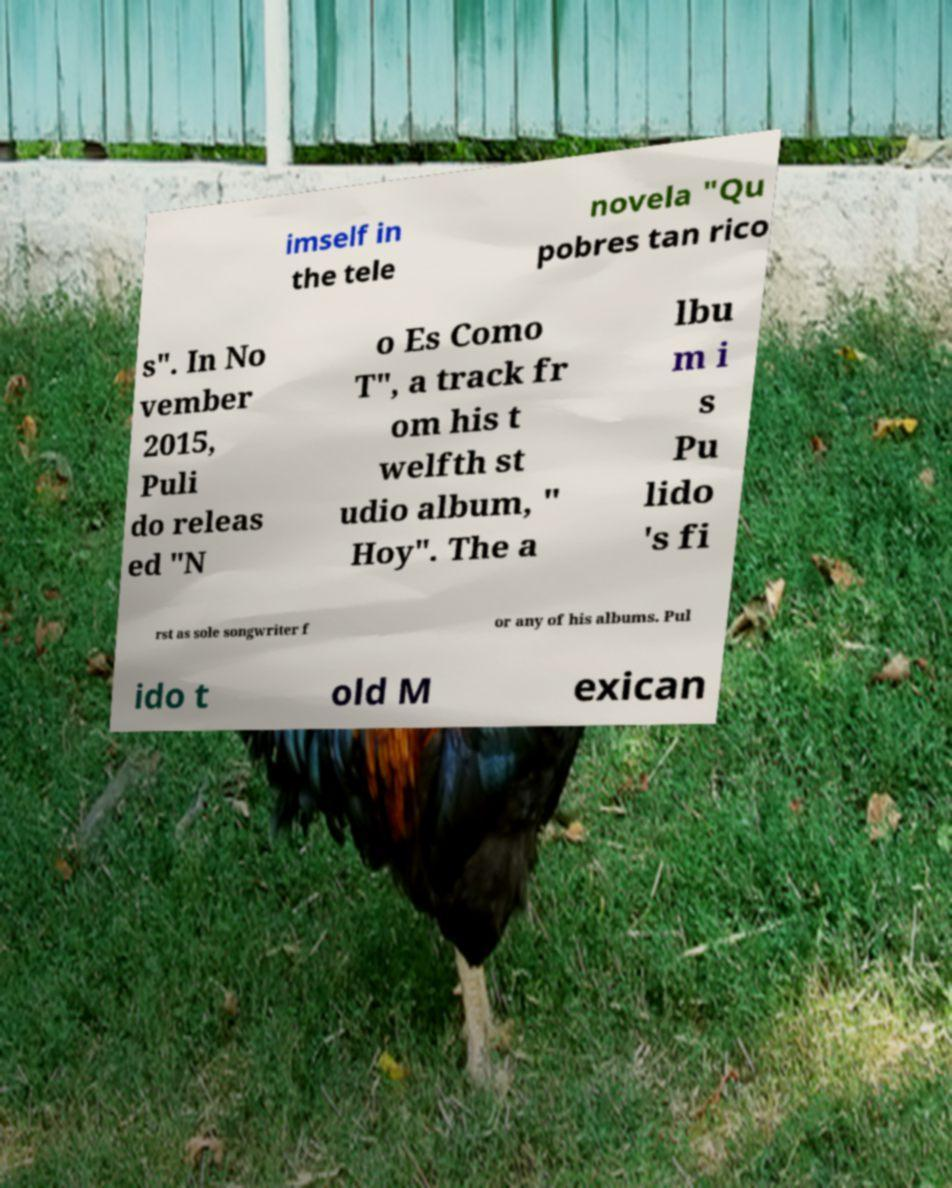Please identify and transcribe the text found in this image. imself in the tele novela "Qu pobres tan rico s". In No vember 2015, Puli do releas ed "N o Es Como T", a track fr om his t welfth st udio album, " Hoy". The a lbu m i s Pu lido 's fi rst as sole songwriter f or any of his albums. Pul ido t old M exican 